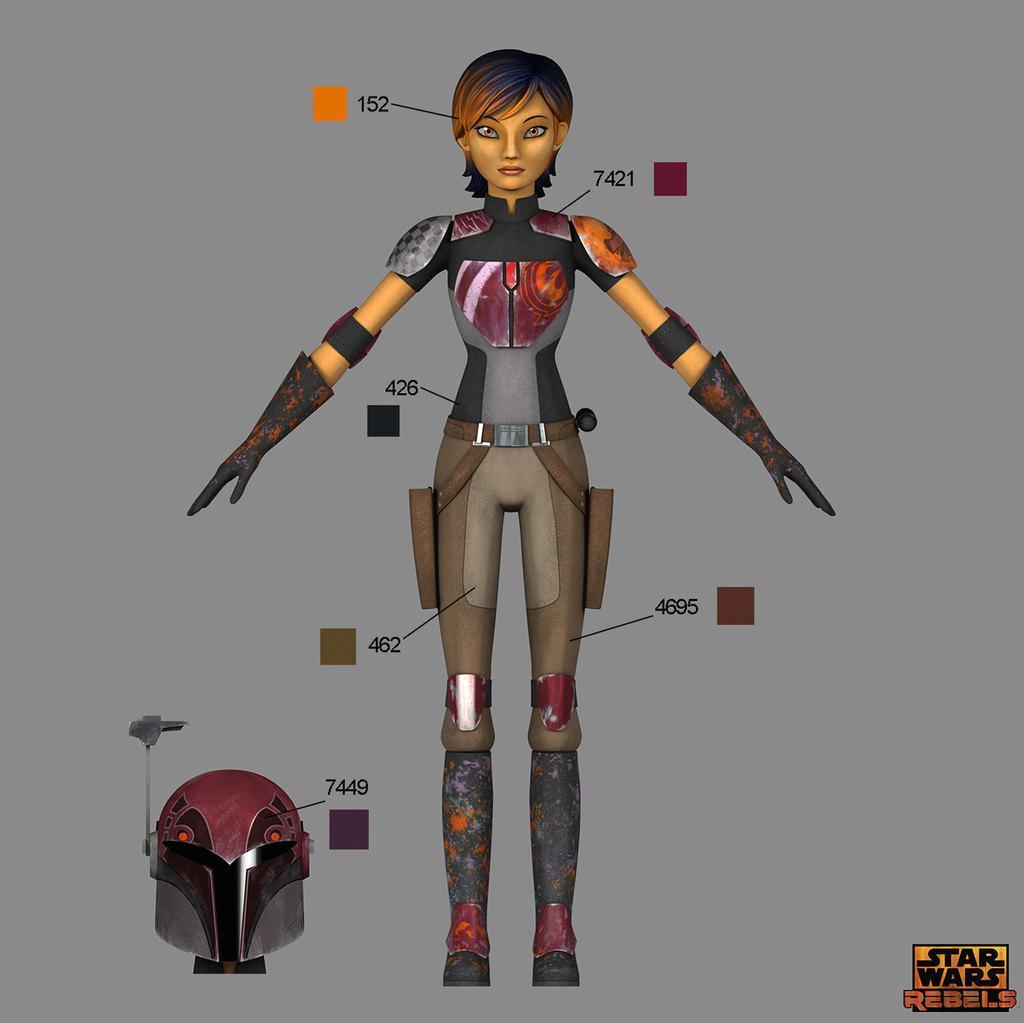Can you describe this image briefly? In this image I can see an animated image of the person. I can also see the helmet. I can see there is a grey color background. 